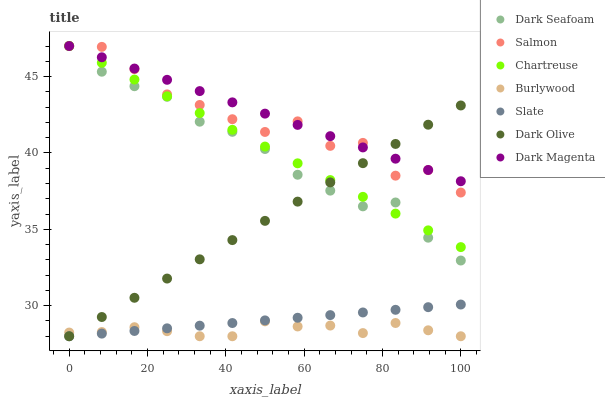Does Burlywood have the minimum area under the curve?
Answer yes or no. Yes. Does Dark Magenta have the maximum area under the curve?
Answer yes or no. Yes. Does Slate have the minimum area under the curve?
Answer yes or no. No. Does Slate have the maximum area under the curve?
Answer yes or no. No. Is Slate the smoothest?
Answer yes or no. Yes. Is Salmon the roughest?
Answer yes or no. Yes. Is Burlywood the smoothest?
Answer yes or no. No. Is Burlywood the roughest?
Answer yes or no. No. Does Burlywood have the lowest value?
Answer yes or no. Yes. Does Salmon have the lowest value?
Answer yes or no. No. Does Dark Seafoam have the highest value?
Answer yes or no. Yes. Does Slate have the highest value?
Answer yes or no. No. Is Slate less than Salmon?
Answer yes or no. Yes. Is Chartreuse greater than Burlywood?
Answer yes or no. Yes. Does Dark Seafoam intersect Dark Olive?
Answer yes or no. Yes. Is Dark Seafoam less than Dark Olive?
Answer yes or no. No. Is Dark Seafoam greater than Dark Olive?
Answer yes or no. No. Does Slate intersect Salmon?
Answer yes or no. No. 